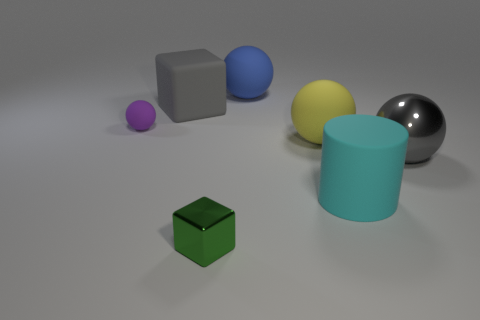How many things are the same color as the big block?
Give a very brief answer. 1. How many other things are there of the same size as the cylinder?
Keep it short and to the point. 4. There is a large metallic thing; is its color the same as the cube behind the tiny purple ball?
Your answer should be compact. Yes. What number of blocks are small green things or big cyan rubber objects?
Your response must be concise. 1. Is there anything else that has the same color as the tiny rubber ball?
Your answer should be compact. No. There is a gray object on the right side of the metallic thing that is in front of the big cyan rubber thing; what is it made of?
Provide a short and direct response. Metal. Does the tiny green block have the same material as the big gray object right of the green block?
Give a very brief answer. Yes. What number of things are either large matte objects that are on the left side of the blue matte sphere or blue matte things?
Offer a terse response. 2. Is there a big block of the same color as the shiny ball?
Provide a succinct answer. Yes. Is the shape of the cyan object the same as the shiny object on the right side of the tiny green cube?
Your answer should be compact. No. 